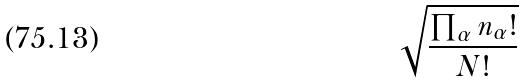<formula> <loc_0><loc_0><loc_500><loc_500>\sqrt { \frac { \prod _ { \alpha } n _ { \alpha } ! } { N ! } }</formula> 